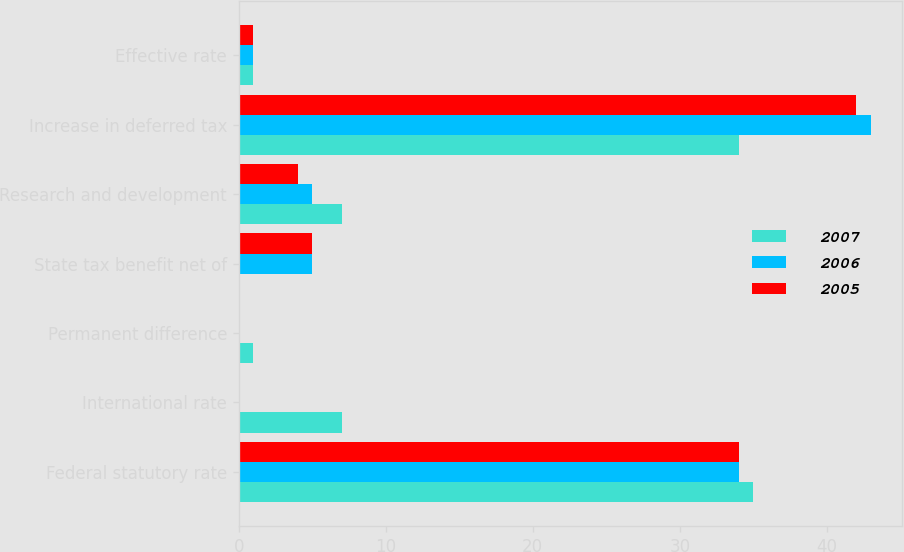Convert chart to OTSL. <chart><loc_0><loc_0><loc_500><loc_500><stacked_bar_chart><ecel><fcel>Federal statutory rate<fcel>International rate<fcel>Permanent difference<fcel>State tax benefit net of<fcel>Research and development<fcel>Increase in deferred tax<fcel>Effective rate<nl><fcel>2007<fcel>35<fcel>7<fcel>1<fcel>0<fcel>7<fcel>34<fcel>1<nl><fcel>2006<fcel>34<fcel>0<fcel>0<fcel>5<fcel>5<fcel>43<fcel>1<nl><fcel>2005<fcel>34<fcel>0<fcel>0<fcel>5<fcel>4<fcel>42<fcel>1<nl></chart> 